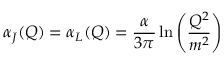Convert formula to latex. <formula><loc_0><loc_0><loc_500><loc_500>\alpha _ { J } ( Q ) = \alpha _ { L } ( Q ) = \frac { \alpha } { 3 \pi } \ln \left ( \frac { Q ^ { 2 } } { m ^ { 2 } } \right )</formula> 